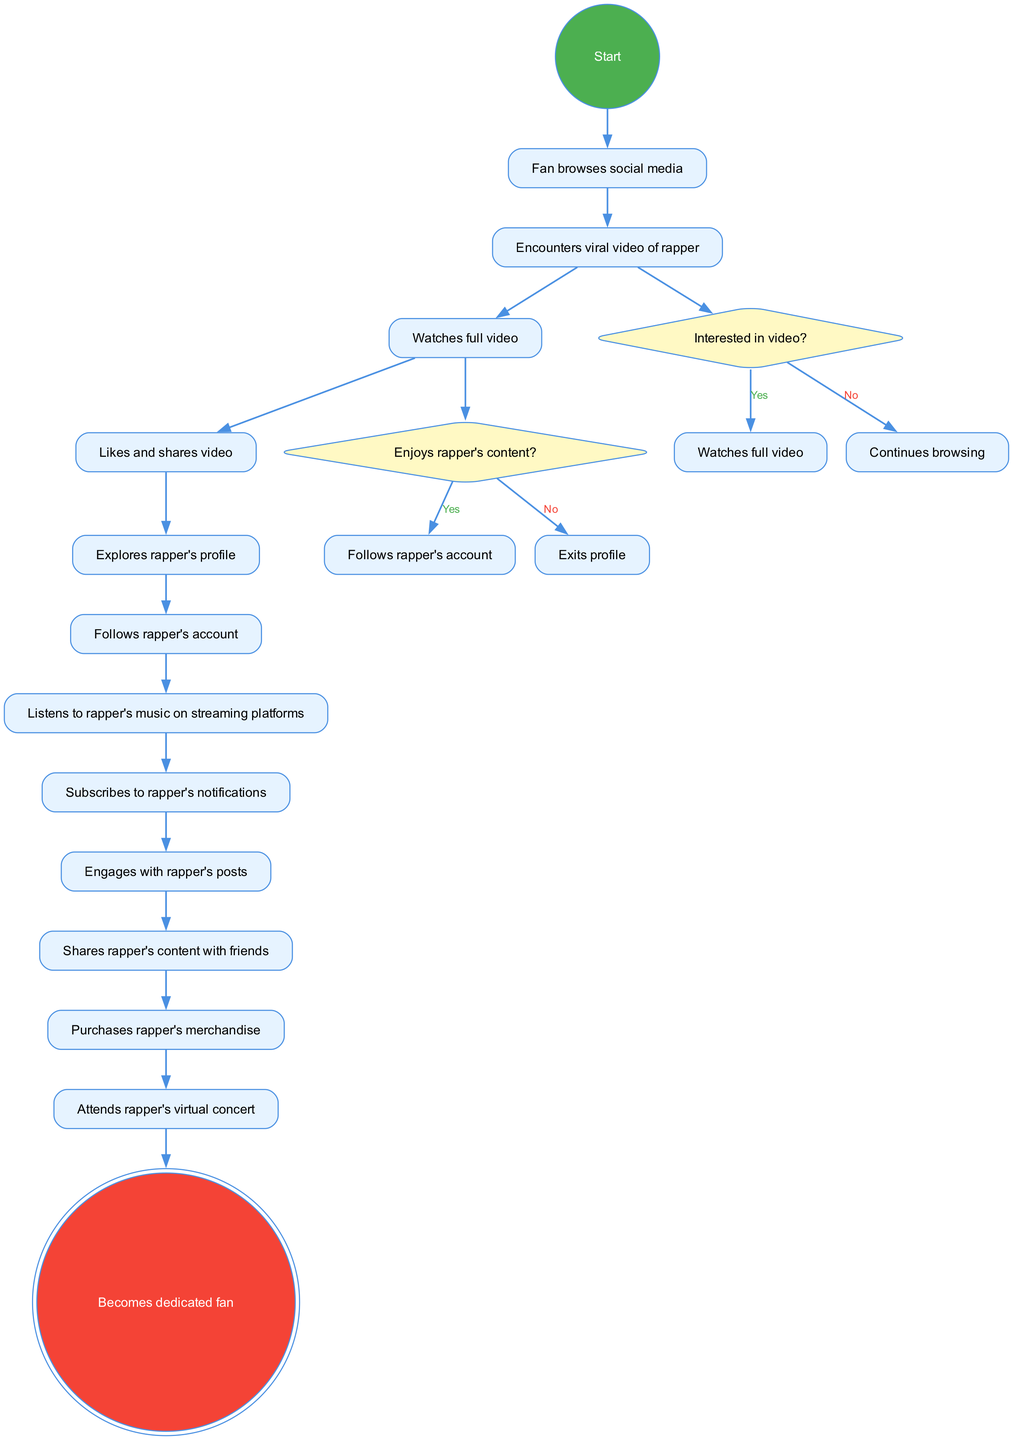What is the initial action for the fan? The initial action is represented by the initial node, which states "Fan browses social media." This is the starting point of the journey in the diagram.
Answer: Fan browses social media How many activities are listed in the diagram? By counting the activities provided in the diagram, there are 11 activities total. Each activity is represented as a distinct node.
Answer: 11 What does the decision node ask about the viral video? The decision node asks, "Interested in video?" This is the first decision point for the fan after encountering the video.
Answer: Interested in video? What action follows if the fan enjoys the rapper's content? If the fan enjoys the rapper's content, the next action is to "Follows rapper's account," which signifies their decision to become a follower.
Answer: Follows rapper's account What happens if the fan does not enjoy the content? If the fan does not enjoy the content, they will "Exits profile," which means they leave the rapper's social media profile and do not continue engaging.
Answer: Exits profile How does the fan end their journey in the diagram? The journey concludes at the final node labeled "Becomes dedicated fan," which indicates the ultimate goal of the journey through various activities.
Answer: Becomes dedicated fan Which activity occurs just before the fan subscribes to notifications? The activity that occurs just before the fan subscribes to notifications is "Follows rapper's account." This step is essential for receiving updates.
Answer: Follows rapper's account What is the relationship between liking a video and sharing it? The diagram shows a sequence where "Likes and shares video" follows immediately after "Watches full video," indicating that the fan reacts positively to the video by both liking and sharing.
Answer: Likes and shares video What color is used for the final node in the diagram? The final node is colored in "#F44336," which is a shade of red, indicating the conclusion and significance of becoming a dedicated fan.
Answer: #F44336 